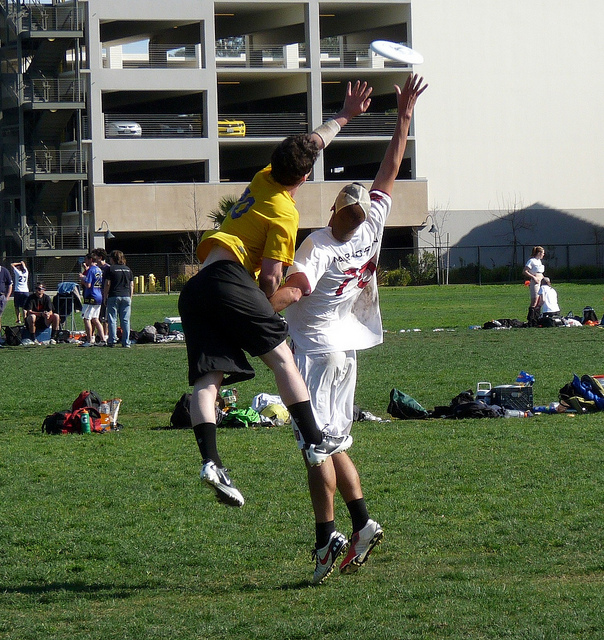Identify the text contained in this image. 2 